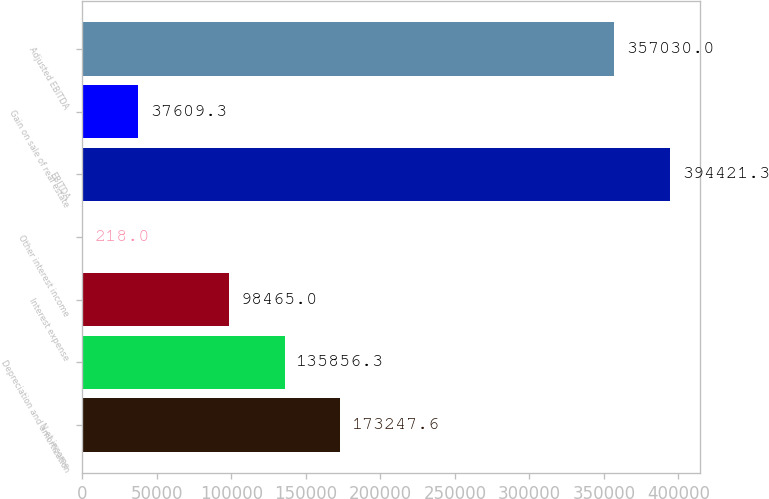Convert chart. <chart><loc_0><loc_0><loc_500><loc_500><bar_chart><fcel>N et income<fcel>Depreciation and amortization<fcel>Interest expense<fcel>Other interest income<fcel>EBITDA<fcel>Gain on sale of real estate<fcel>Adjusted EBITDA<nl><fcel>173248<fcel>135856<fcel>98465<fcel>218<fcel>394421<fcel>37609.3<fcel>357030<nl></chart> 